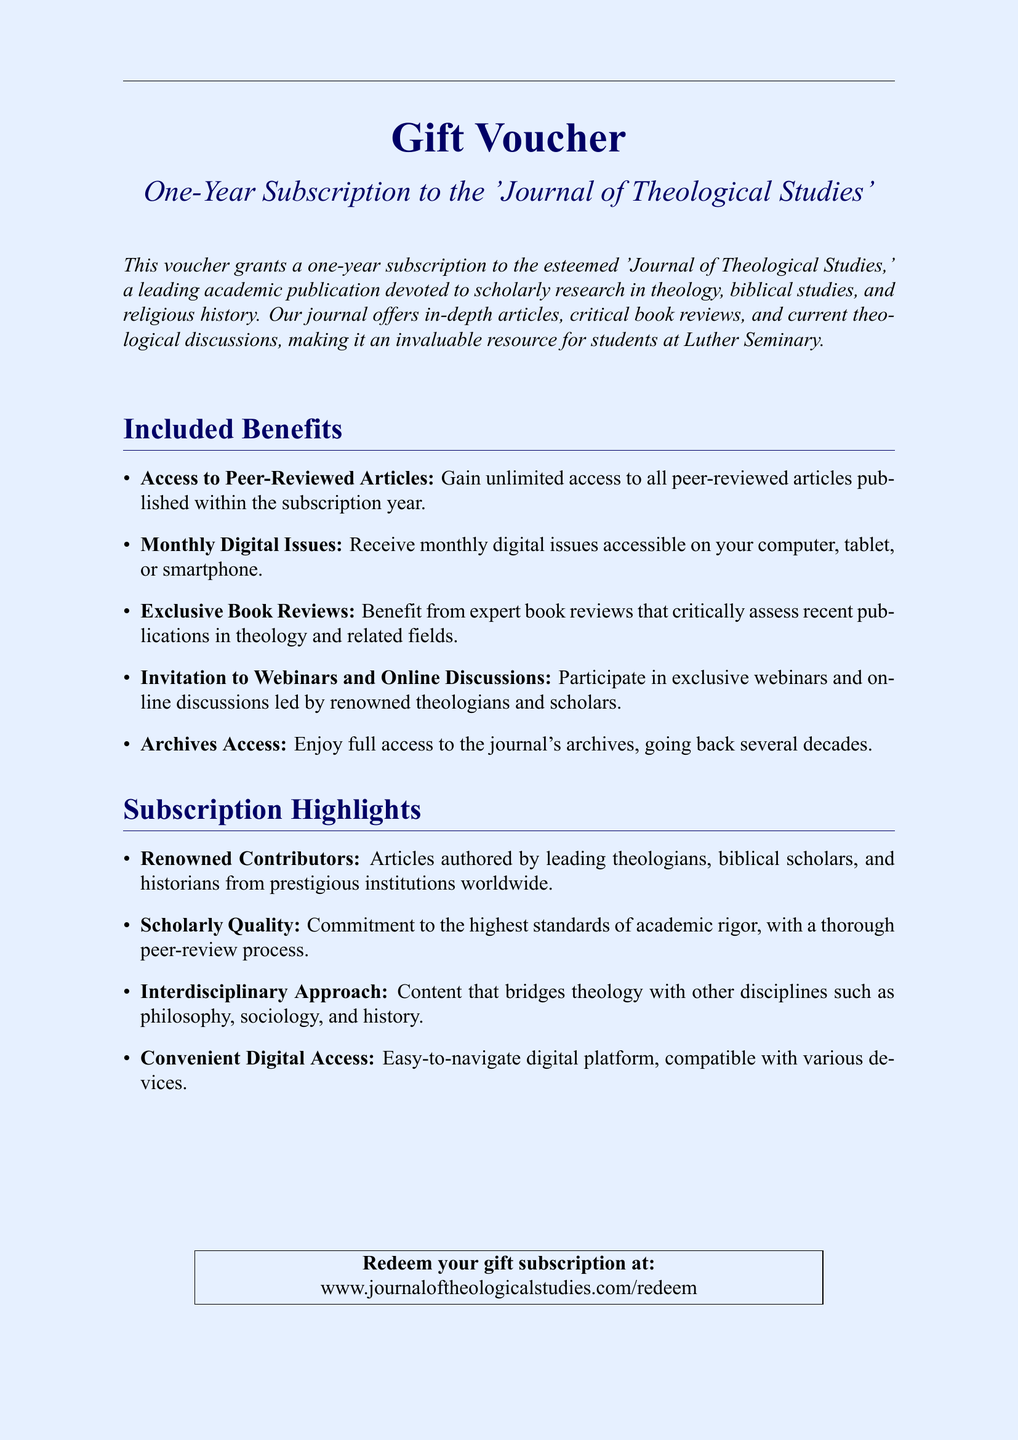What is the name of the journal? The name of the journal is clearly stated in the title of the voucher document, which is 'Journal of Theological Studies'.
Answer: Journal of Theological Studies How long is the subscription valid for? The duration of the subscription is indicated in the title of the document as a one-year subscription.
Answer: One year What type of access is provided to articles? The document specifies that the subscription provides unlimited access to all peer-reviewed articles.
Answer: Unlimited access What is one benefit of the subscription? The document lists several benefits, including access to monthly digital issues.
Answer: Monthly digital issues How can the gift subscription be redeemed? The document provides a specific URL for redeeming the subscription at the end of the document.
Answer: www.journaloftheologicalstudies.com/redeem Who are the contributors to the journal? The document mentions that the contributors are leading theologians, biblical scholars, and historians from prestigious institutions worldwide.
Answer: Leading theologians What is the nature of the journal’s content? The document describes the journal's content as having an interdisciplinary approach, bridging theology with other disciplines.
Answer: Interdisciplinary approach What type of reviews does the journal provide? The document indicates that the journal includes expert book reviews that critically assess recent publications.
Answer: Expert book reviews What is one feature of the digital platform? The document states that the digital platform is convenient and compatible with various devices.
Answer: Compatible with various devices 